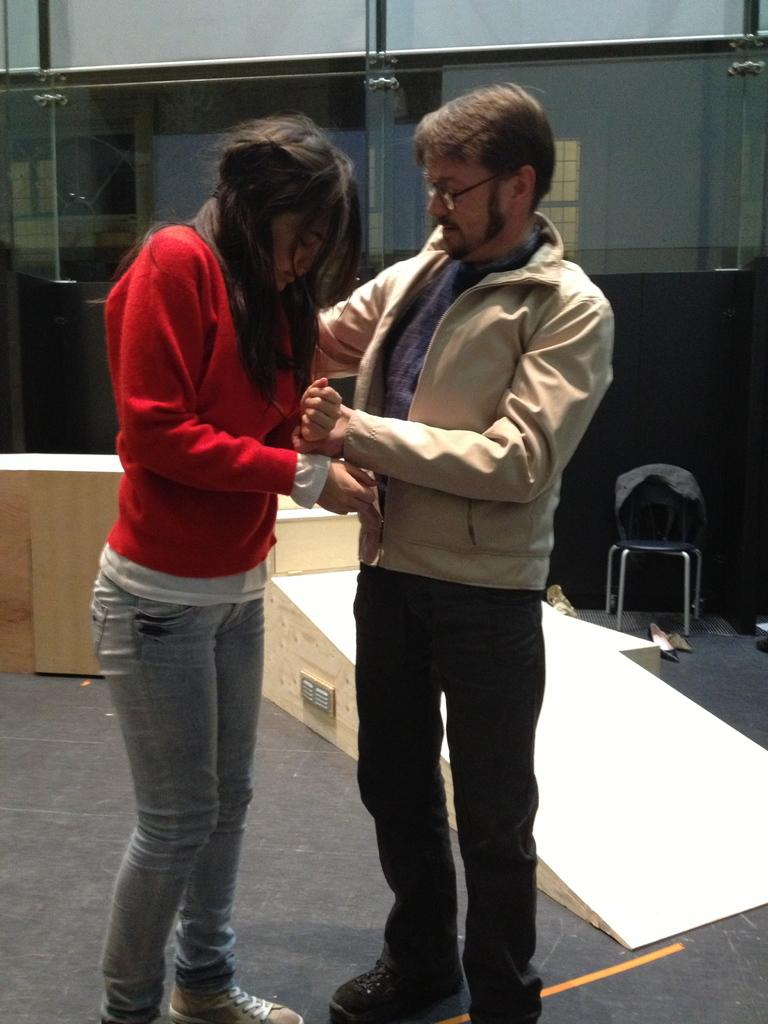What is the gender of the person in the image? There is a lady and a guy in the image. What is the lady wearing in the image? The lady is wearing a red top. What is the guy wearing in the image? The guy is wearing a jacket. Can you describe the background or scene behind the two individuals? Unfortunately, the facts provided do not specify what is behind the two individuals. What type of advice is the lady giving to the guy in the image? There is no indication in the image that the lady is giving advice to the guy. How many cakes are visible in the image? There are no cakes present in the image. 